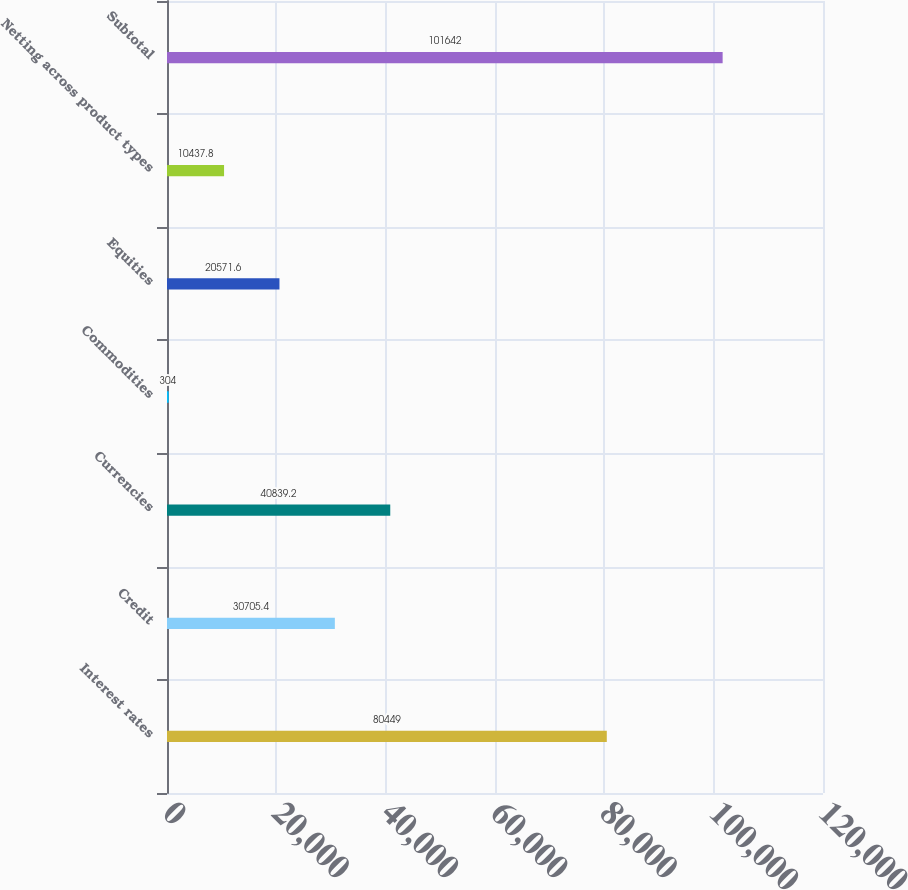Convert chart. <chart><loc_0><loc_0><loc_500><loc_500><bar_chart><fcel>Interest rates<fcel>Credit<fcel>Currencies<fcel>Commodities<fcel>Equities<fcel>Netting across product types<fcel>Subtotal<nl><fcel>80449<fcel>30705.4<fcel>40839.2<fcel>304<fcel>20571.6<fcel>10437.8<fcel>101642<nl></chart> 